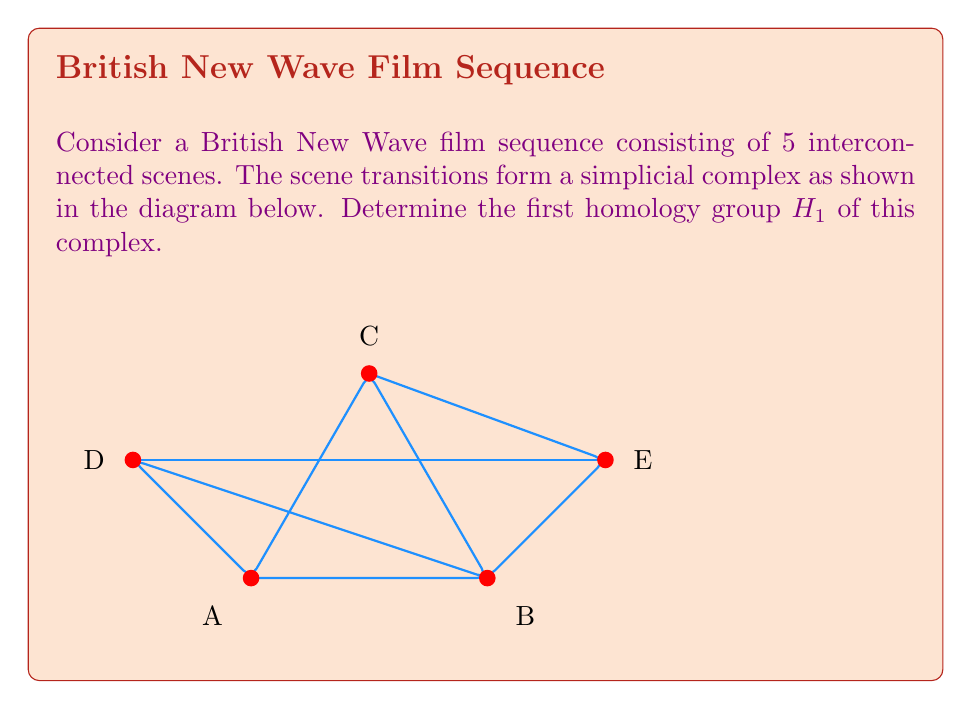What is the answer to this math problem? Let's approach this step-by-step:

1) First, we need to identify the simplices in each dimension:
   0-simplices: A, B, C, D, E
   1-simplices: AB, BC, CA, AD, DB, BE, EC, DE

2) Next, we calculate the chain groups:
   $C_0 = \mathbb{Z}^5$ (5 vertices)
   $C_1 = \mathbb{Z}^8$ (8 edges)
   $C_2 = \mathbb{Z}^2$ (2 triangles: ABC and BDE)

3) Now, we need to compute the boundary maps:
   $\partial_2: C_2 \to C_1$
   $\partial_1: C_1 \to C_0$

4) The kernel of $\partial_1$ (cycles) is generated by:
   $z_1 = AB + BC - CA$
   $z_2 = DB + BE - DE$
   $z_3 = AD + DB + BE + EC - DE - CA$

5) The image of $\partial_2$ (boundaries) is generated by:
   $b_1 = AB + BC - CA$
   $b_2 = DB + BE - DE$

6) The first homology group $H_1$ is defined as:
   $H_1 = \text{ker}(\partial_1) / \text{im}(\partial_2)$

7) We can see that $z_1$ and $z_2$ are boundaries, but $z_3$ is not. Therefore, $H_1$ is generated by one element, which is represented by $z_3$.

8) Since there are no relations on this generator, $H_1$ is isomorphic to $\mathbb{Z}$.
Answer: $H_1 \cong \mathbb{Z}$ 